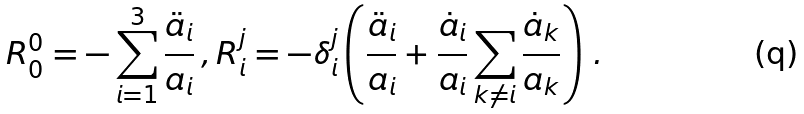<formula> <loc_0><loc_0><loc_500><loc_500>R _ { 0 } ^ { 0 } = - \sum _ { i = 1 } ^ { 3 } \frac { \ddot { a } _ { i } } { a _ { i } } \, , R _ { i } ^ { j } = - \delta _ { i } ^ { j } \left ( \frac { \ddot { a } _ { i } } { a _ { i } } + \frac { \dot { a } _ { i } } { a _ { i } } \sum _ { k \neq i } \frac { \dot { a } _ { k } } { a _ { k } } \right ) \, .</formula> 